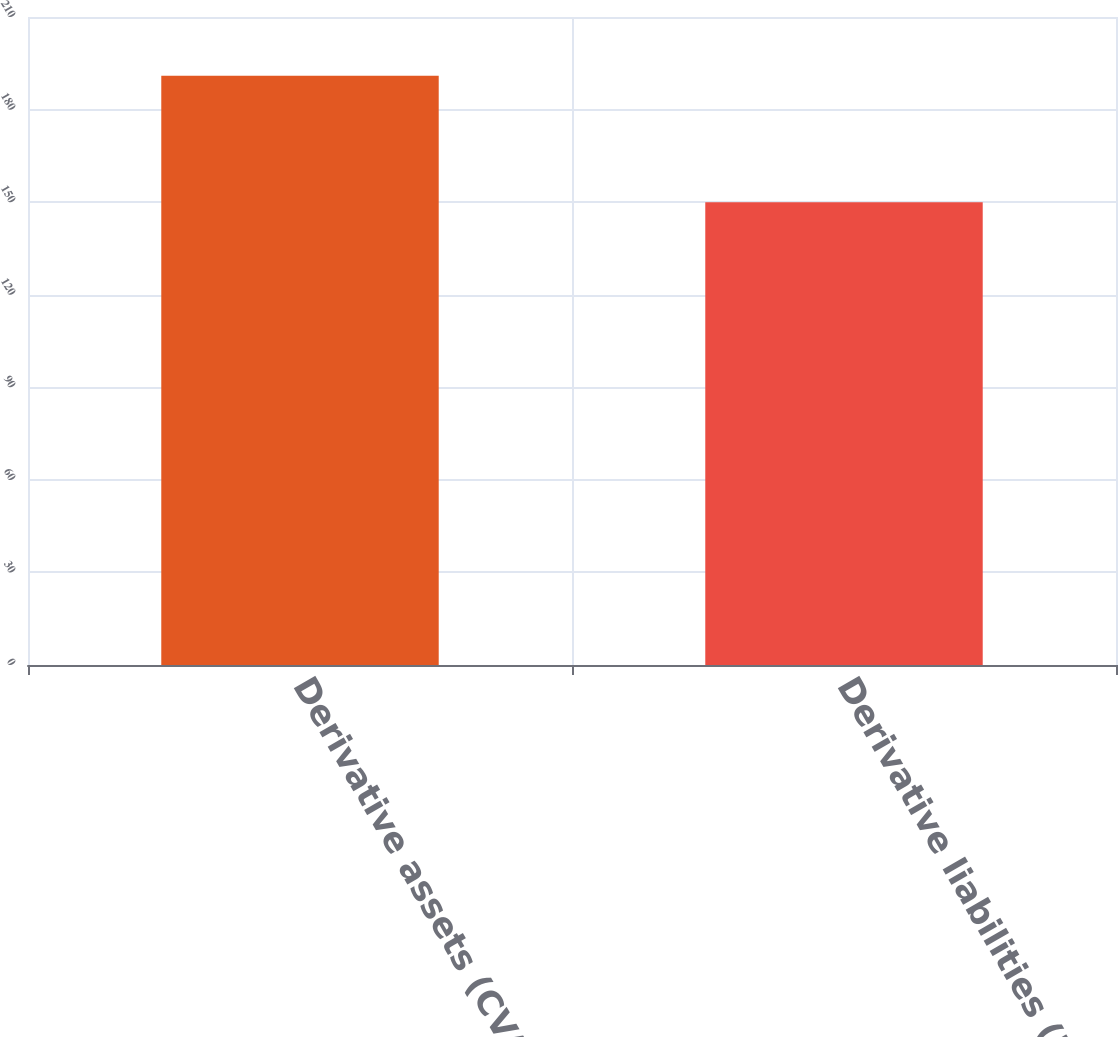Convert chart. <chart><loc_0><loc_0><loc_500><loc_500><bar_chart><fcel>Derivative assets (CVA) (1)<fcel>Derivative liabilities (DVA)<nl><fcel>191<fcel>150<nl></chart> 